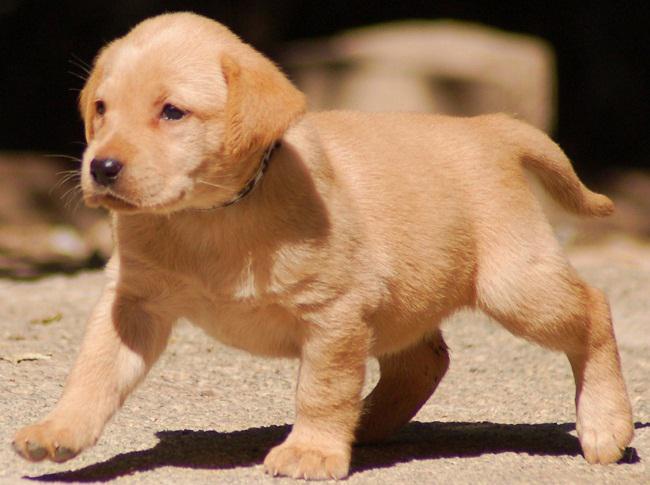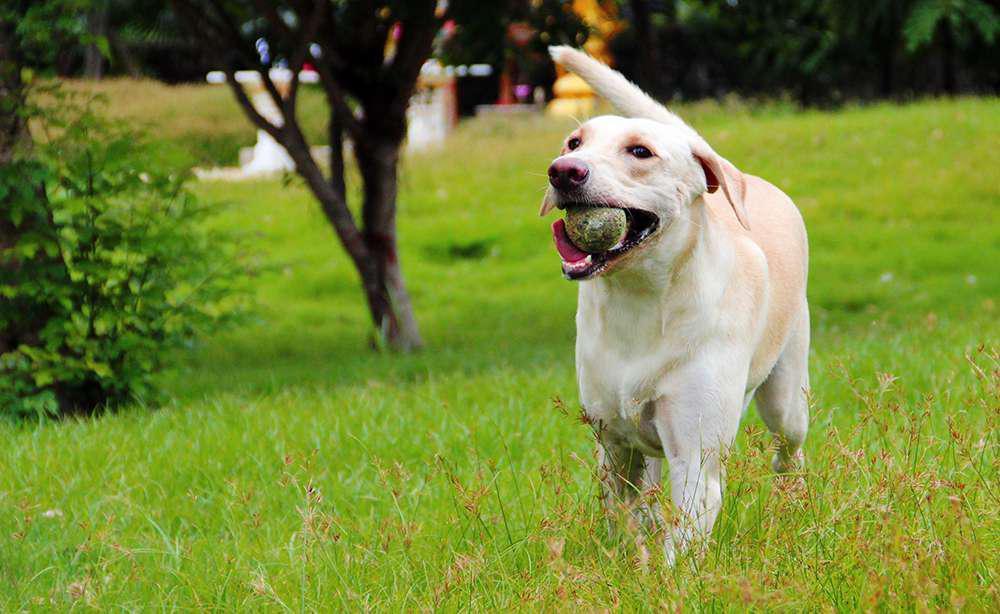The first image is the image on the left, the second image is the image on the right. Given the left and right images, does the statement "One of the animals is not on the grass." hold true? Answer yes or no. Yes. 